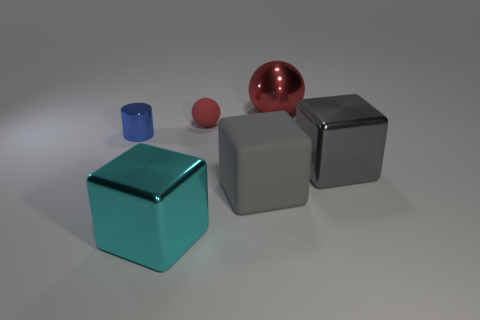Subtract all large metallic blocks. How many blocks are left? 1 Add 4 large brown metal spheres. How many objects exist? 10 Subtract all cyan spheres. How many gray cubes are left? 2 Subtract all cylinders. How many objects are left? 5 Subtract all matte balls. Subtract all large red balls. How many objects are left? 4 Add 6 blue metallic objects. How many blue metallic objects are left? 7 Add 1 red spheres. How many red spheres exist? 3 Subtract 0 yellow spheres. How many objects are left? 6 